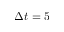Convert formula to latex. <formula><loc_0><loc_0><loc_500><loc_500>\Delta t = 5</formula> 